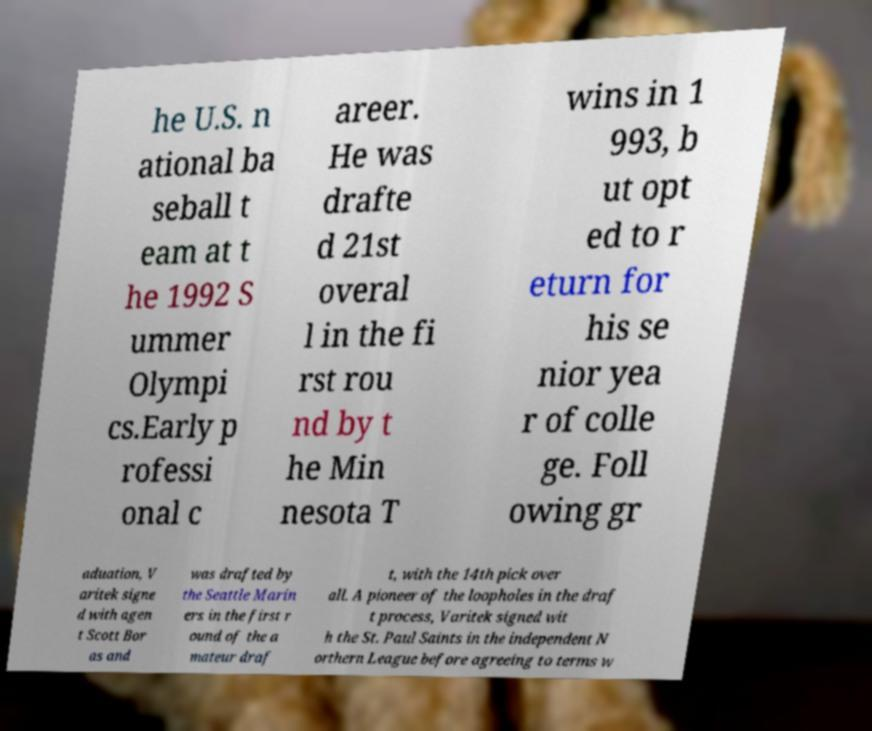Can you read and provide the text displayed in the image?This photo seems to have some interesting text. Can you extract and type it out for me? he U.S. n ational ba seball t eam at t he 1992 S ummer Olympi cs.Early p rofessi onal c areer. He was drafte d 21st overal l in the fi rst rou nd by t he Min nesota T wins in 1 993, b ut opt ed to r eturn for his se nior yea r of colle ge. Foll owing gr aduation, V aritek signe d with agen t Scott Bor as and was drafted by the Seattle Marin ers in the first r ound of the a mateur draf t, with the 14th pick over all. A pioneer of the loopholes in the draf t process, Varitek signed wit h the St. Paul Saints in the independent N orthern League before agreeing to terms w 